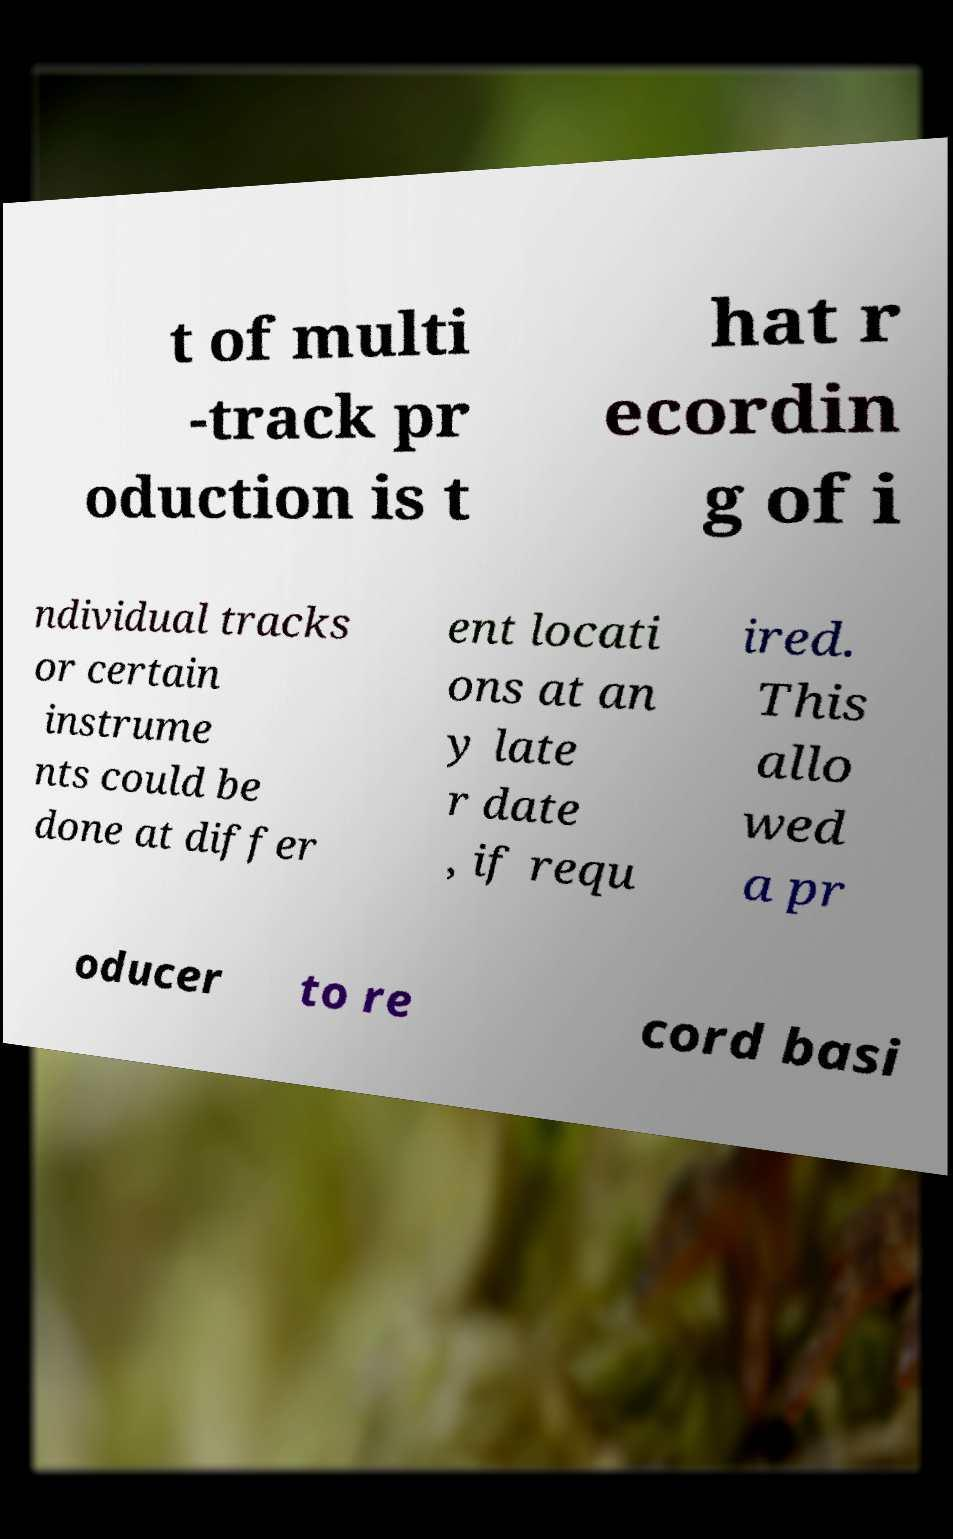Please identify and transcribe the text found in this image. t of multi -track pr oduction is t hat r ecordin g of i ndividual tracks or certain instrume nts could be done at differ ent locati ons at an y late r date , if requ ired. This allo wed a pr oducer to re cord basi 